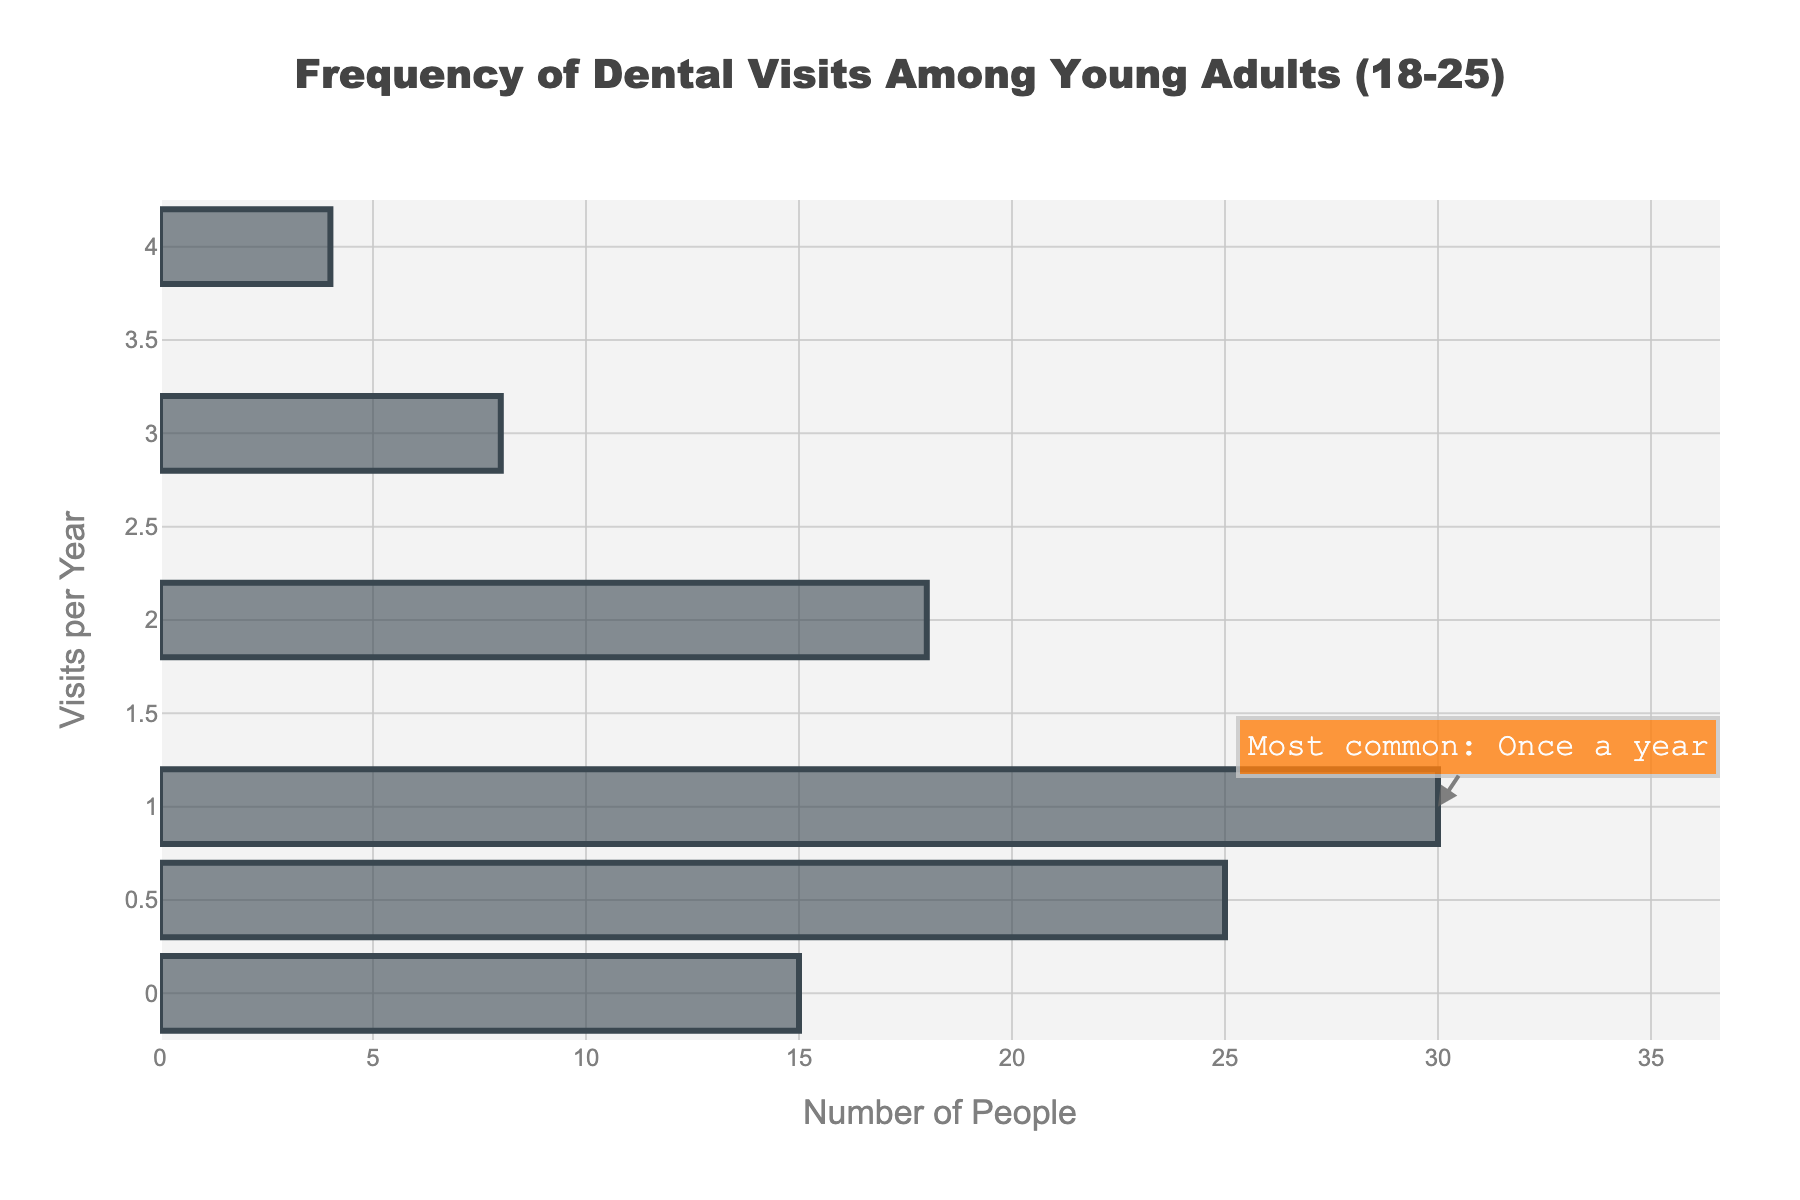What is the most common number of dental visits per year among young adults aged 18-25? The annotation on the plot indicates that once a year is the most common frequency for dental visits.
Answer: Once a year How many young adults visit the dentist zero times per year? According to the bar for zero visits per year on the y-axis, the frequency is 15.
Answer: 15 How many young adults visit the dentist half a time per year? According to the bar for 0.5 visits per year on the y-axis, the frequency is 25.
Answer: 25 What is the title of the plot? The title of the plot is displayed at the top center and reads "Frequency of Dental Visits Among Young Adults (18-25)".
Answer: Frequency of Dental Visits Among Young Adults (18-25) How many total young adults participated in the survey? Add the frequencies for all visits per year: 15 (0 visits) + 25 (0.5 visits) + 30 (1 visit) + 18 (2 visits) + 8 (3 visits) + 4 (4 visits) = 100.
Answer: 100 Which category of dental visits has the least frequency? The bar with the smallest frequency corresponds to 4 visits per year, which has a frequency of 4.
Answer: 4 visits per year How many more young adults visit the dentist once a year compared to twice a year? The frequency for once a year is 30, and for twice a year is 18. Thus, the difference is 30 - 18 = 12.
Answer: 12 What is the combined frequency of young adults who visit the dentist either 0.5 or 1 times per year? Sum the frequencies for 0.5 visits per year (25) and 1 visit per year (30): 25 + 30 = 55.
Answer: 55 How many times more young adults visit the dentist once a year compared to three times a year? The frequency for once a year is 30, and for three times a year is 8. Thus, 30 / 8 = 3.75.
Answer: 3.75 times Which visit frequency has a higher rate: half a year or three times a year? Comparing the bars, the frequency for 0.5 visits per year is 25, while three times a year is 8. Thus, 0.5 visits per year has a higher frequency.
Answer: Half a year 